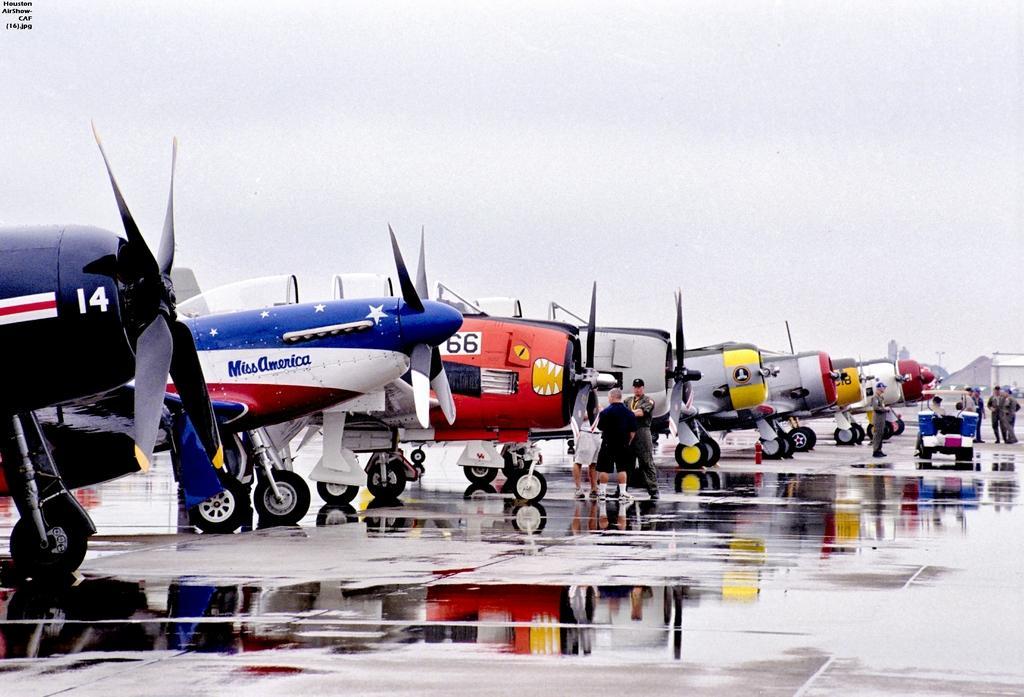Please provide a concise description of this image. In this image we can see the people standing on the ground. And we can see a vehicle. There are airplanes on the ground. In the background, we can see the sky. 